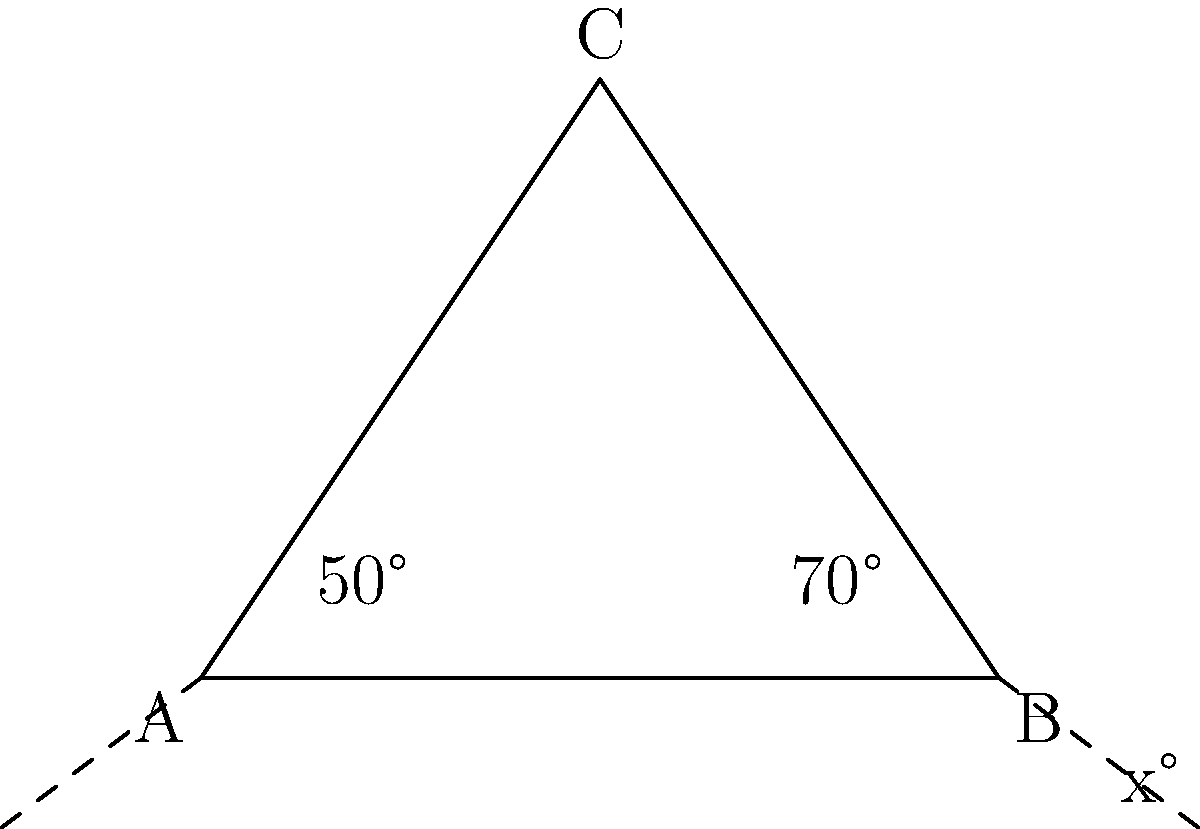In the triangle ABC shown above, the interior angles at A and B are 50° and 70° respectively. What is the measure of the exterior angle at point B, denoted as x°? Let's solve this step-by-step using Python-like logic:

1. First, recall that the sum of interior angles of a triangle is always 180°.

2. We can find the third interior angle (at C) by subtracting the known angles from 180°:
   ```python
   angle_C = 180 - (50 + 70)
   angle_C = 60
   ```

3. Now, remember that an exterior angle of a triangle is supplementary to the interior angle at the same vertex. This means they add up to 180°.

4. So, we can find the exterior angle x° by subtracting the interior angle at B from 180°:
   ```python
   x = 180 - 70
   x = 110
   ```

Therefore, the measure of the exterior angle at point B (x°) is 110°.
Answer: 110° 